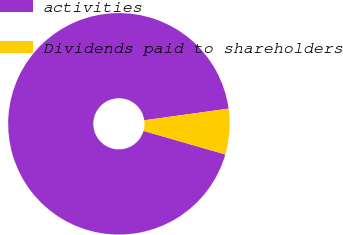Convert chart to OTSL. <chart><loc_0><loc_0><loc_500><loc_500><pie_chart><fcel>activities<fcel>Dividends paid to shareholders<nl><fcel>93.35%<fcel>6.65%<nl></chart> 